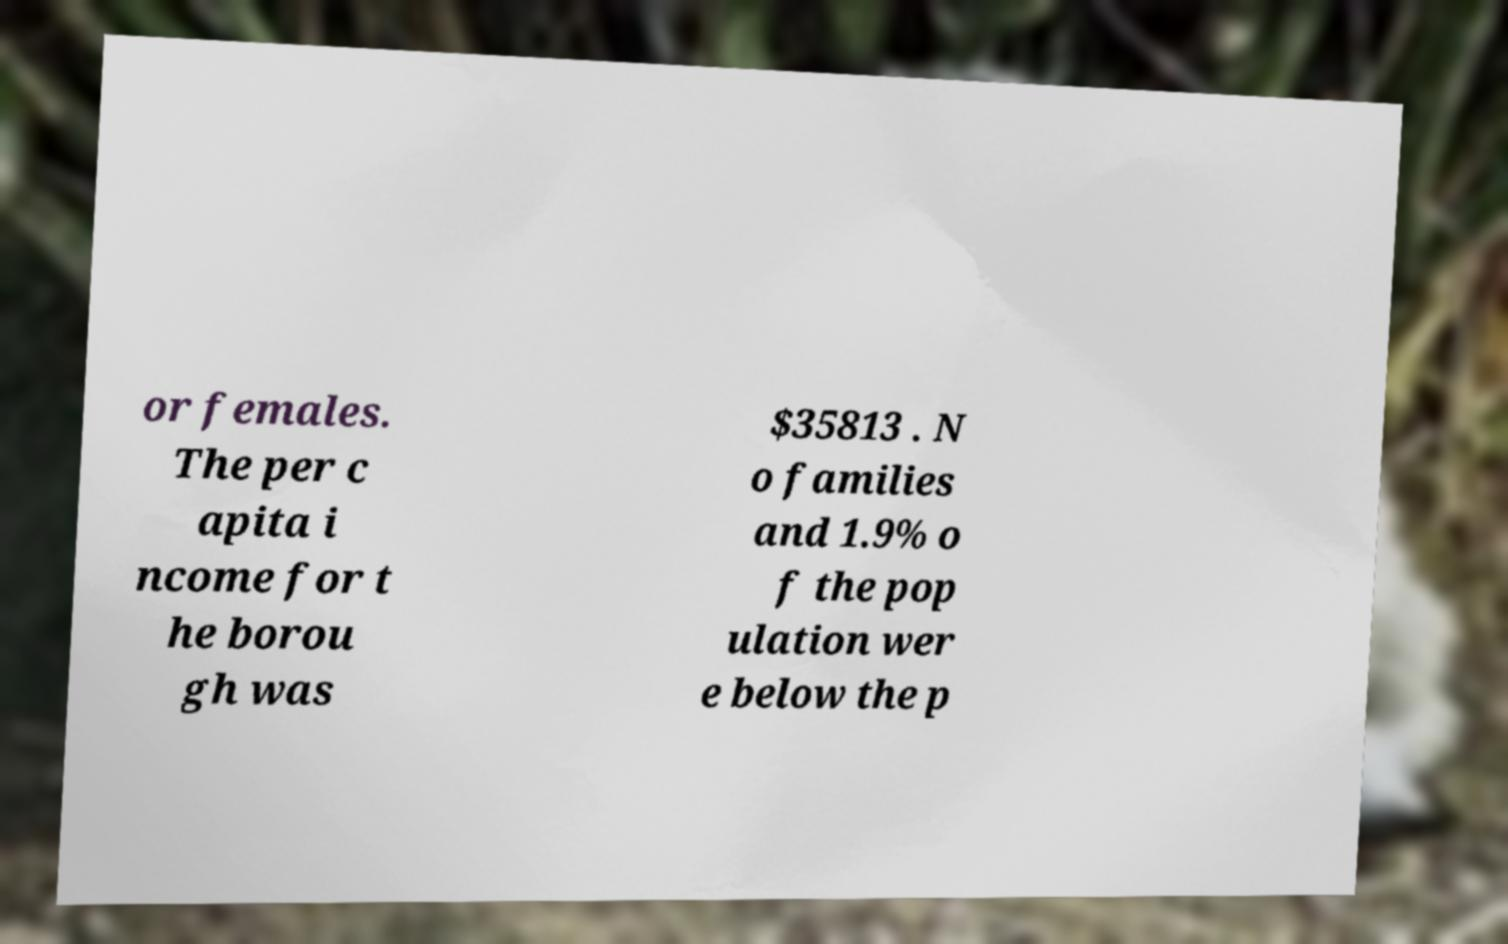Please identify and transcribe the text found in this image. or females. The per c apita i ncome for t he borou gh was $35813 . N o families and 1.9% o f the pop ulation wer e below the p 